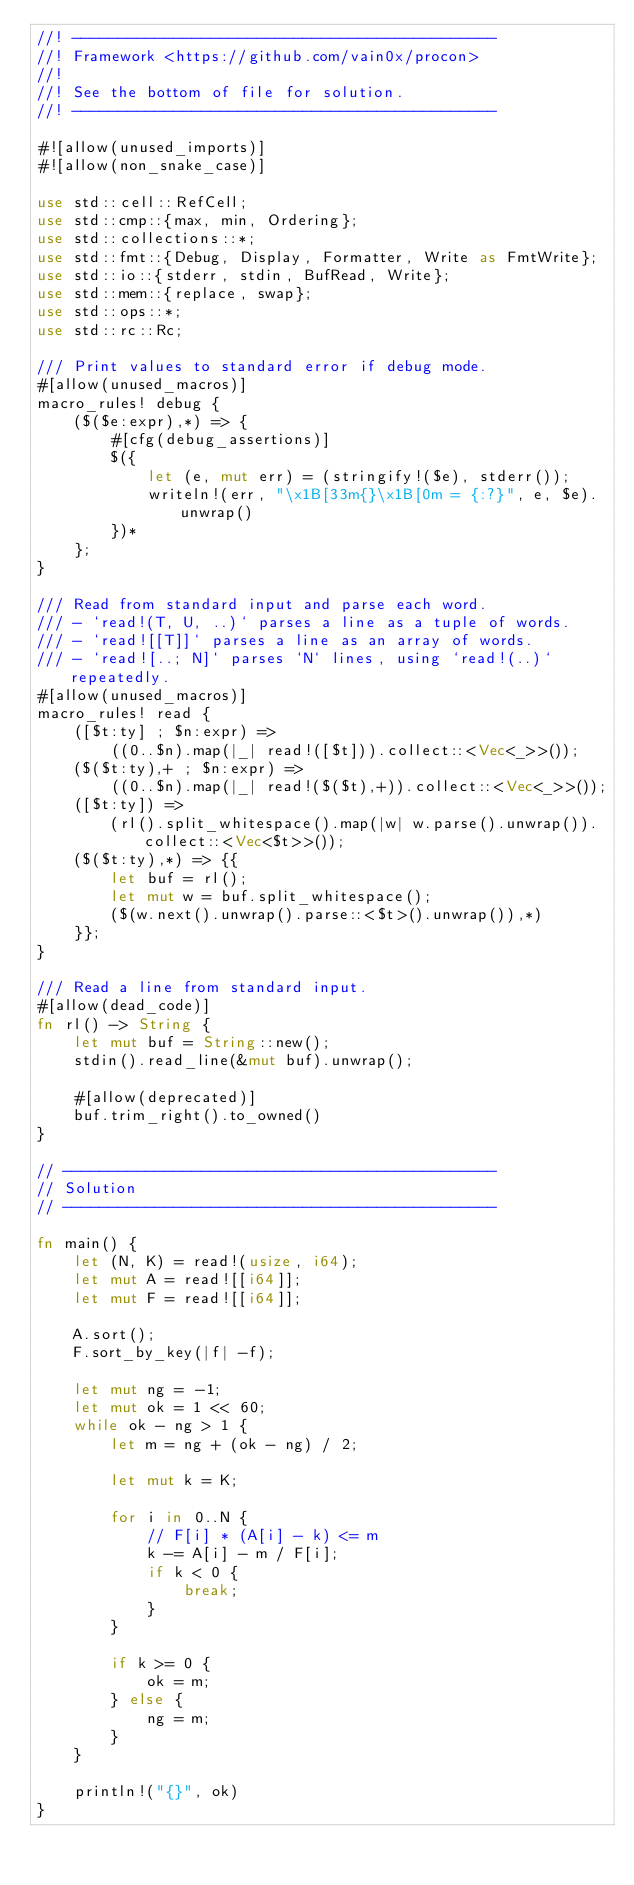Convert code to text. <code><loc_0><loc_0><loc_500><loc_500><_Rust_>//! ----------------------------------------------
//! Framework <https://github.com/vain0x/procon>
//!
//! See the bottom of file for solution.
//! ----------------------------------------------

#![allow(unused_imports)]
#![allow(non_snake_case)]

use std::cell::RefCell;
use std::cmp::{max, min, Ordering};
use std::collections::*;
use std::fmt::{Debug, Display, Formatter, Write as FmtWrite};
use std::io::{stderr, stdin, BufRead, Write};
use std::mem::{replace, swap};
use std::ops::*;
use std::rc::Rc;

/// Print values to standard error if debug mode.
#[allow(unused_macros)]
macro_rules! debug {
    ($($e:expr),*) => {
        #[cfg(debug_assertions)]
        $({
            let (e, mut err) = (stringify!($e), stderr());
            writeln!(err, "\x1B[33m{}\x1B[0m = {:?}", e, $e).unwrap()
        })*
    };
}

/// Read from standard input and parse each word.
/// - `read!(T, U, ..)` parses a line as a tuple of words.
/// - `read![[T]]` parses a line as an array of words.
/// - `read![..; N]` parses `N` lines, using `read!(..)` repeatedly.
#[allow(unused_macros)]
macro_rules! read {
    ([$t:ty] ; $n:expr) =>
        ((0..$n).map(|_| read!([$t])).collect::<Vec<_>>());
    ($($t:ty),+ ; $n:expr) =>
        ((0..$n).map(|_| read!($($t),+)).collect::<Vec<_>>());
    ([$t:ty]) =>
        (rl().split_whitespace().map(|w| w.parse().unwrap()).collect::<Vec<$t>>());
    ($($t:ty),*) => {{
        let buf = rl();
        let mut w = buf.split_whitespace();
        ($(w.next().unwrap().parse::<$t>().unwrap()),*)
    }};
}

/// Read a line from standard input.
#[allow(dead_code)]
fn rl() -> String {
    let mut buf = String::new();
    stdin().read_line(&mut buf).unwrap();

    #[allow(deprecated)]
    buf.trim_right().to_owned()
}

// -----------------------------------------------
// Solution
// -----------------------------------------------

fn main() {
    let (N, K) = read!(usize, i64);
    let mut A = read![[i64]];
    let mut F = read![[i64]];

    A.sort();
    F.sort_by_key(|f| -f);

    let mut ng = -1;
    let mut ok = 1 << 60;
    while ok - ng > 1 {
        let m = ng + (ok - ng) / 2;

        let mut k = K;

        for i in 0..N {
            // F[i] * (A[i] - k) <= m
            k -= A[i] - m / F[i];
            if k < 0 {
                break;
            }
        }

        if k >= 0 {
            ok = m;
        } else {
            ng = m;
        }
    }

    println!("{}", ok)
}
</code> 